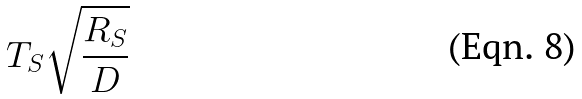Convert formula to latex. <formula><loc_0><loc_0><loc_500><loc_500>T _ { S } \sqrt { \frac { R _ { S } } { D } }</formula> 